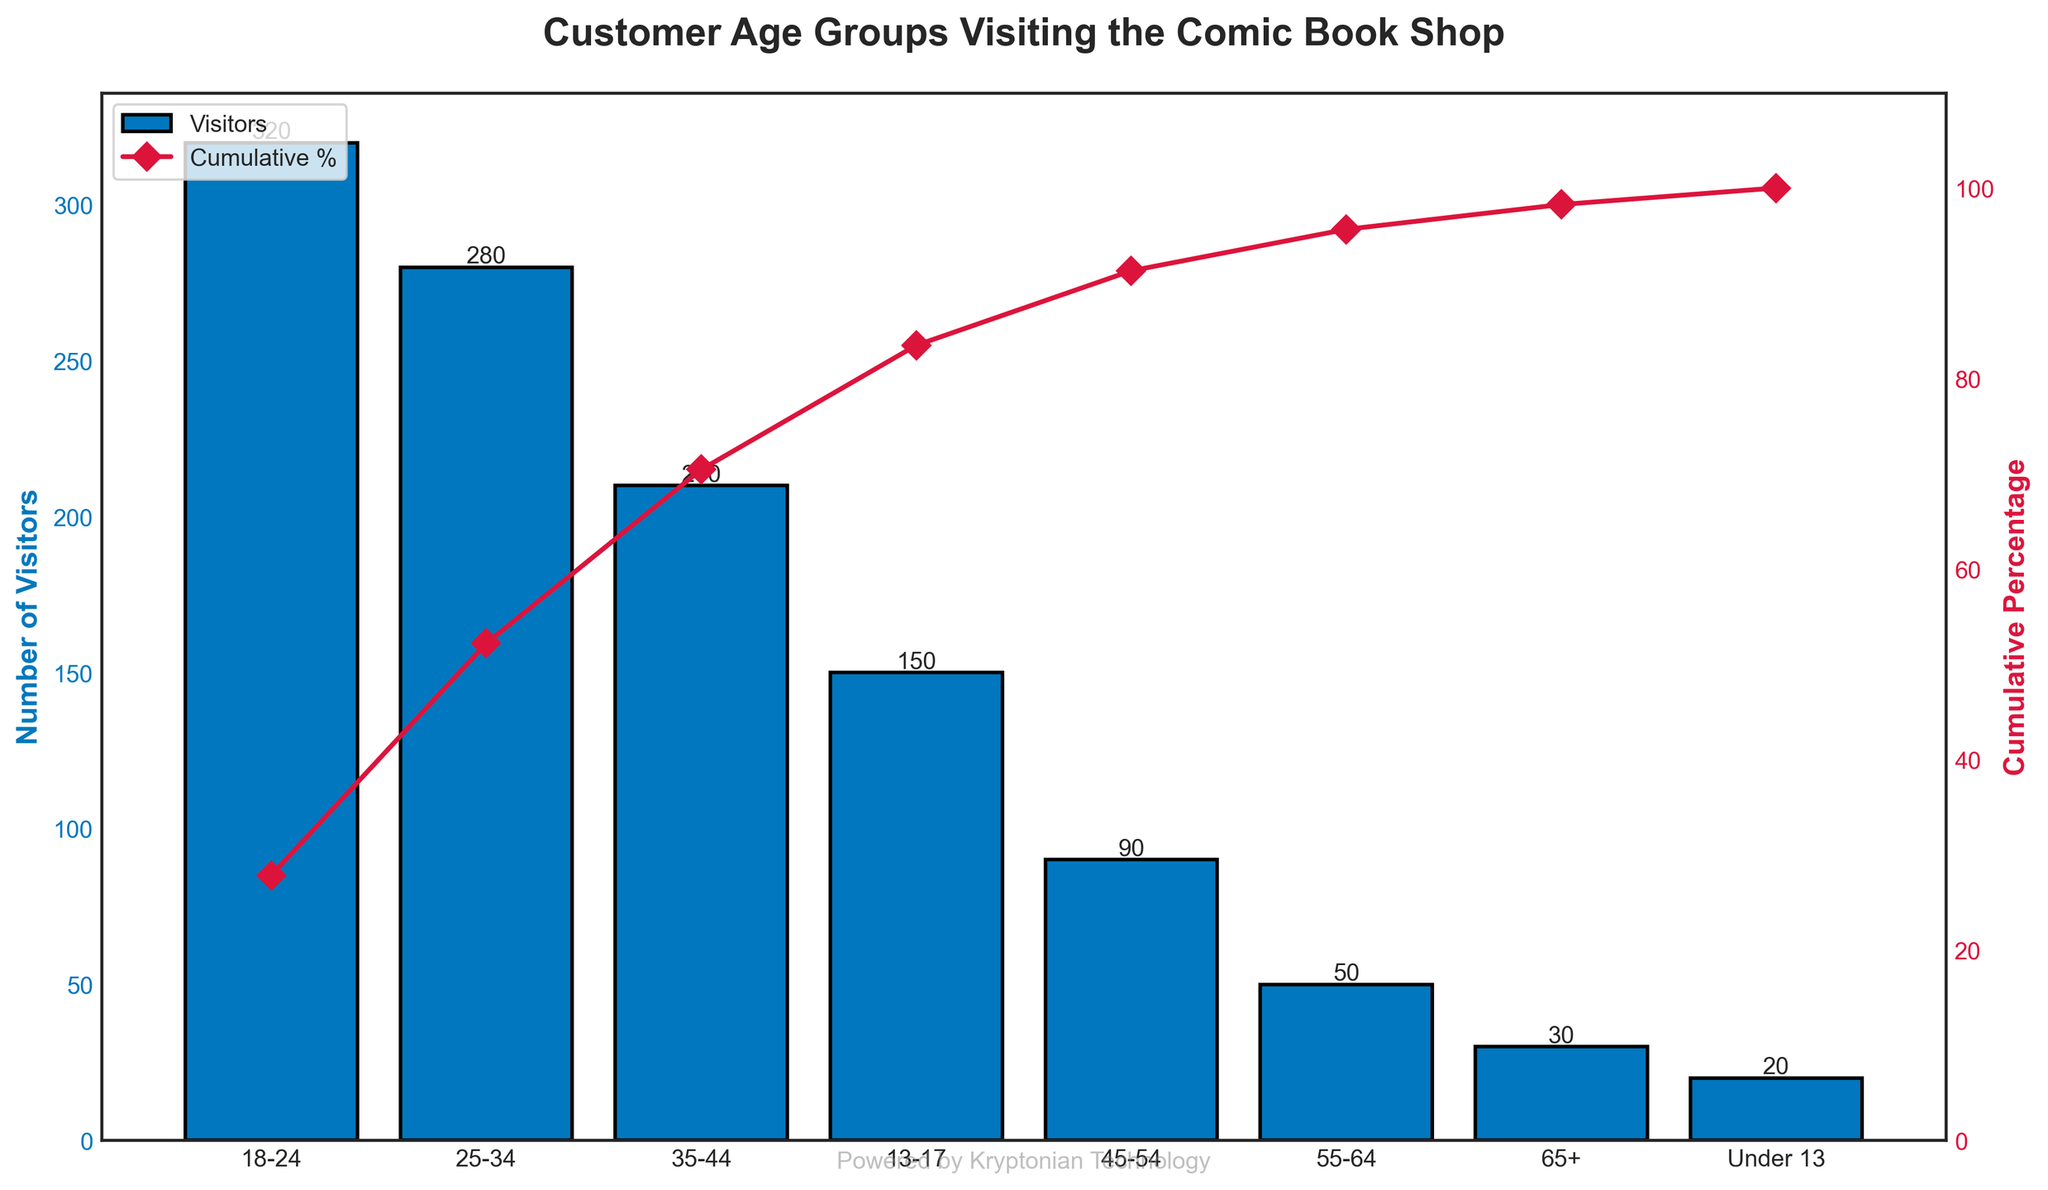What is the title of the plot? The title of the plot is prominently displayed at the top and reads "Customer Age Groups Visiting the Comic Book Shop".
Answer: Customer Age Groups Visiting the Comic Book Shop Which age group has the highest number of visitors? By looking at the heights of the bars, the age group 18-24 has the tallest bar, indicating it has the highest number of visitors.
Answer: 18-24 How many visitors are there in the 35-44 age group? The bar corresponding to the 35-44 age group has a label on top of it showing the exact number of visitors, which is 210.
Answer: 210 What is the cumulative percentage up to the 35-44 age group? The cumulative percentage line shows that the cumulative percentage up to the 35-44 group is approximately 75%.
Answer: 75% Which two age groups together make up more than half of the total visitors? By examining the cumulative percentage line, we see that the sum of visitors from the 18-24 and 25-34 age groups surpasses 50%, as the cumulative percentage reaches slightly over 60% after these two groups.
Answer: 18-24 and 25-34 What is the difference in the number of visitors between the 25-34 and 35-44 age groups? The number of visitors in the 25-34 age group is 280, and in the 35-44 age group is 210. Subtracting the two gives 280 - 210 = 70.
Answer: 70 Which age group has the lowest number of visitors? By observing the shortest bar, the age group with the lowest number of visitors is Under 13, which has only 20 visitors.
Answer: Under 13 What percentage of visitors are from the age group 55-64? The cumulative percentage plot and the data show that the age group 55-64 has 50 visitors. To compute the percentage: (50 / 1150) * 100 ≈ 4.35%.
Answer: 4.35% Approximately what is the cumulative percentage of visitors up to the 45-54 age group? The cumulative percentage line shows that up to the 45-54 age group, the cumulative percentage is close to 90%.
Answer: 90% How many age groups have a number of visitors less than 100? By looking at the bars whose labels indicate values less than 100, the age groups 45-54 (90 visitors), 55-64 (50 visitors), 65+ (30 visitors), and Under 13 (20 visitors) meet this criterion. There are four such groups.
Answer: 4 